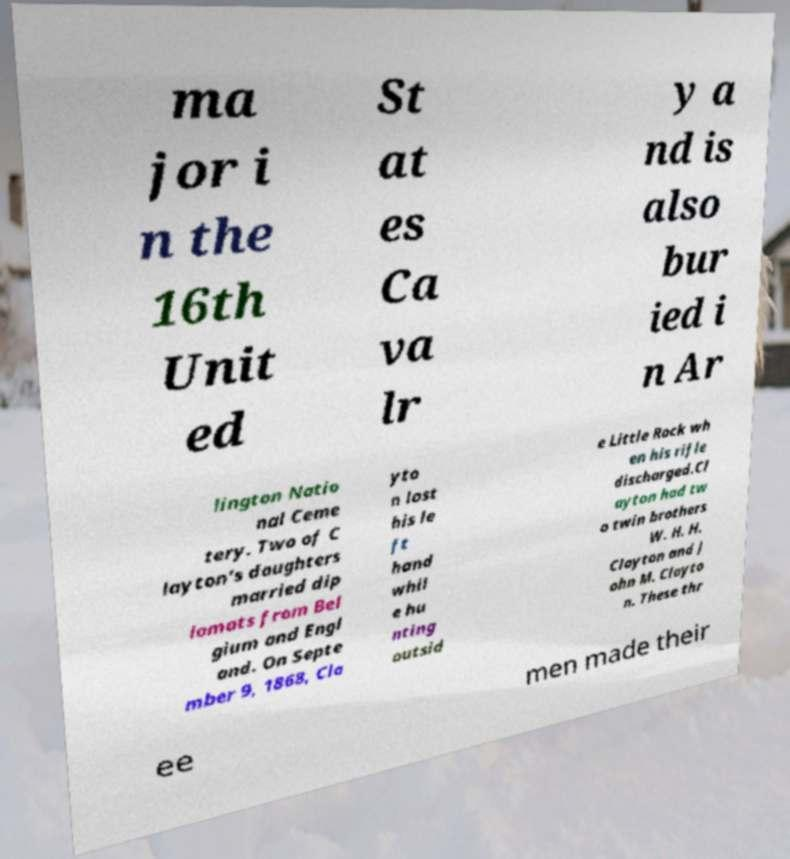What messages or text are displayed in this image? I need them in a readable, typed format. ma jor i n the 16th Unit ed St at es Ca va lr y a nd is also bur ied i n Ar lington Natio nal Ceme tery. Two of C layton's daughters married dip lomats from Bel gium and Engl and. On Septe mber 9, 1868, Cla yto n lost his le ft hand whil e hu nting outsid e Little Rock wh en his rifle discharged.Cl ayton had tw o twin brothers W. H. H. Clayton and J ohn M. Clayto n. These thr ee men made their 